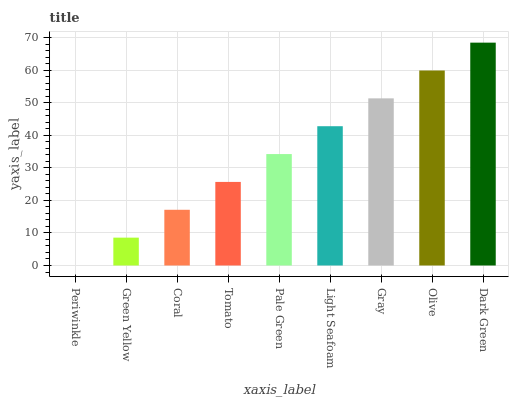Is Periwinkle the minimum?
Answer yes or no. Yes. Is Dark Green the maximum?
Answer yes or no. Yes. Is Green Yellow the minimum?
Answer yes or no. No. Is Green Yellow the maximum?
Answer yes or no. No. Is Green Yellow greater than Periwinkle?
Answer yes or no. Yes. Is Periwinkle less than Green Yellow?
Answer yes or no. Yes. Is Periwinkle greater than Green Yellow?
Answer yes or no. No. Is Green Yellow less than Periwinkle?
Answer yes or no. No. Is Pale Green the high median?
Answer yes or no. Yes. Is Pale Green the low median?
Answer yes or no. Yes. Is Tomato the high median?
Answer yes or no. No. Is Olive the low median?
Answer yes or no. No. 